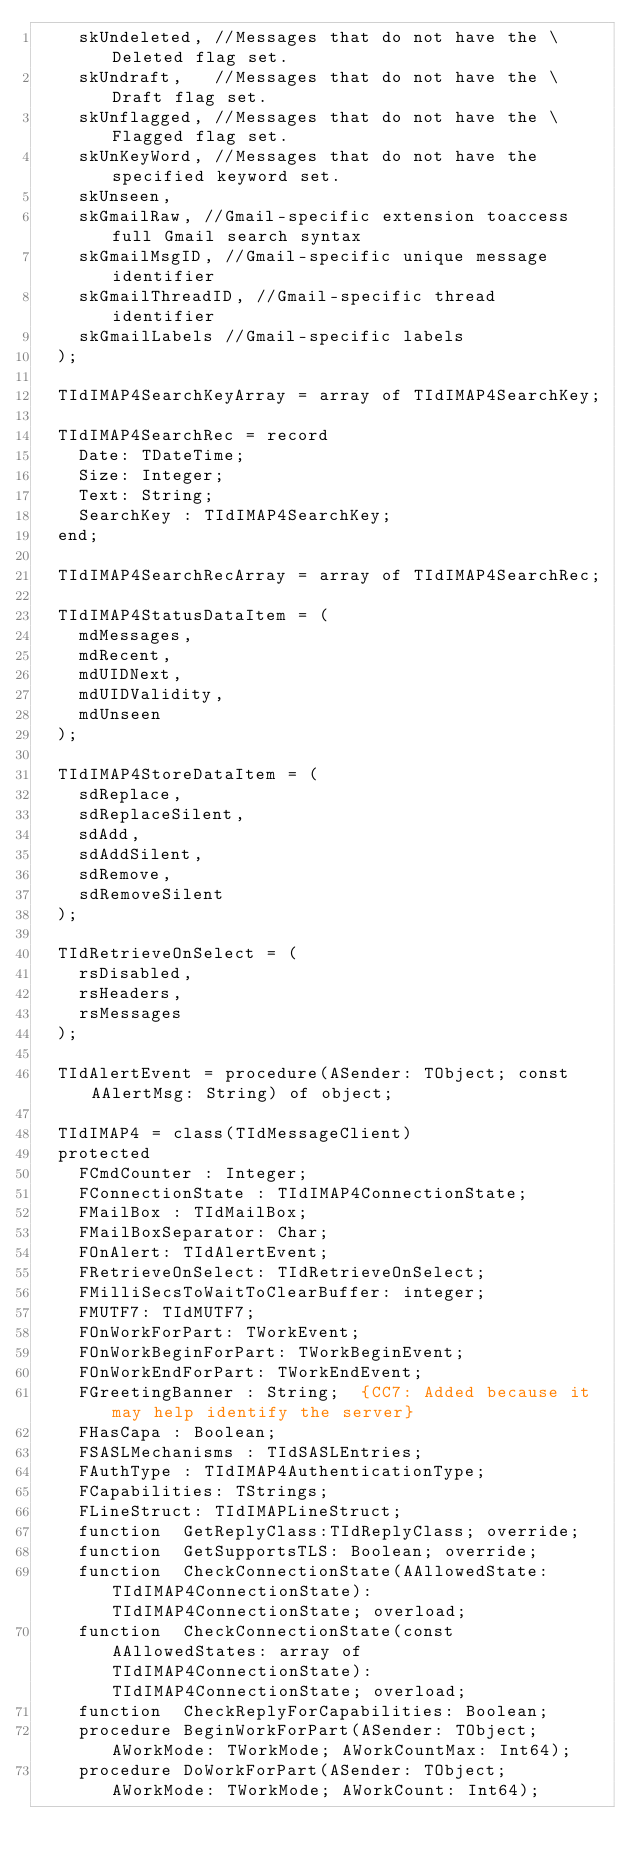<code> <loc_0><loc_0><loc_500><loc_500><_Pascal_>    skUndeleted, //Messages that do not have the \Deleted flag set.
    skUndraft,   //Messages that do not have the \Draft flag set.
    skUnflagged, //Messages that do not have the \Flagged flag set.
    skUnKeyWord, //Messages that do not have the specified keyword set.
    skUnseen,
    skGmailRaw, //Gmail-specific extension toaccess full Gmail search syntax
    skGmailMsgID, //Gmail-specific unique message identifier
    skGmailThreadID, //Gmail-specific thread identifier
    skGmailLabels //Gmail-specific labels
  );

  TIdIMAP4SearchKeyArray = array of TIdIMAP4SearchKey;

  TIdIMAP4SearchRec = record
    Date: TDateTime;
    Size: Integer;
    Text: String;
    SearchKey : TIdIMAP4SearchKey;
  end;

  TIdIMAP4SearchRecArray = array of TIdIMAP4SearchRec;

  TIdIMAP4StatusDataItem = (
    mdMessages,
    mdRecent,
    mdUIDNext,
    mdUIDValidity,
    mdUnseen
  );

  TIdIMAP4StoreDataItem = (
    sdReplace,
    sdReplaceSilent,
    sdAdd,
    sdAddSilent,
    sdRemove,
    sdRemoveSilent
  );

  TIdRetrieveOnSelect = (
    rsDisabled,
    rsHeaders,
    rsMessages
  );

  TIdAlertEvent = procedure(ASender: TObject; const AAlertMsg: String) of object;

  TIdIMAP4 = class(TIdMessageClient)
  protected
    FCmdCounter : Integer;
    FConnectionState : TIdIMAP4ConnectionState;
    FMailBox : TIdMailBox;
    FMailBoxSeparator: Char;
    FOnAlert: TIdAlertEvent;
    FRetrieveOnSelect: TIdRetrieveOnSelect;
    FMilliSecsToWaitToClearBuffer: integer;
    FMUTF7: TIdMUTF7;
    FOnWorkForPart: TWorkEvent;
    FOnWorkBeginForPart: TWorkBeginEvent;
    FOnWorkEndForPart: TWorkEndEvent;
    FGreetingBanner : String;  {CC7: Added because it may help identify the server}
    FHasCapa : Boolean;
    FSASLMechanisms : TIdSASLEntries;
    FAuthType : TIdIMAP4AuthenticationType;
    FCapabilities: TStrings;
    FLineStruct: TIdIMAPLineStruct;
    function  GetReplyClass:TIdReplyClass; override;
    function  GetSupportsTLS: Boolean; override;
    function  CheckConnectionState(AAllowedState: TIdIMAP4ConnectionState): TIdIMAP4ConnectionState; overload;
    function  CheckConnectionState(const AAllowedStates: array of TIdIMAP4ConnectionState): TIdIMAP4ConnectionState; overload;
    function  CheckReplyForCapabilities: Boolean;
    procedure BeginWorkForPart(ASender: TObject; AWorkMode: TWorkMode; AWorkCountMax: Int64);
    procedure DoWorkForPart(ASender: TObject; AWorkMode: TWorkMode; AWorkCount: Int64);</code> 